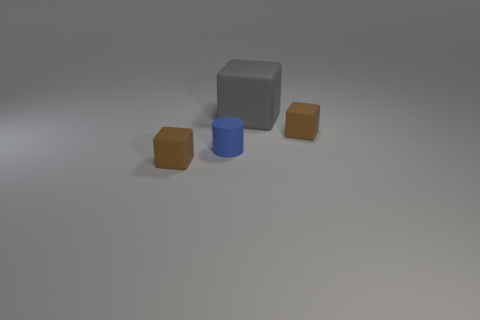Subtract 1 blocks. How many blocks are left? 2 Subtract all small cubes. How many cubes are left? 1 Add 1 large yellow metallic spheres. How many objects exist? 5 Subtract all cubes. How many objects are left? 1 Add 1 blue things. How many blue things exist? 2 Subtract 0 gray cylinders. How many objects are left? 4 Subtract all big rubber things. Subtract all brown objects. How many objects are left? 1 Add 1 gray rubber cubes. How many gray rubber cubes are left? 2 